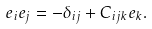<formula> <loc_0><loc_0><loc_500><loc_500>e _ { i } e _ { j } = - \delta _ { i j } + C _ { i j k } e _ { k } .</formula> 